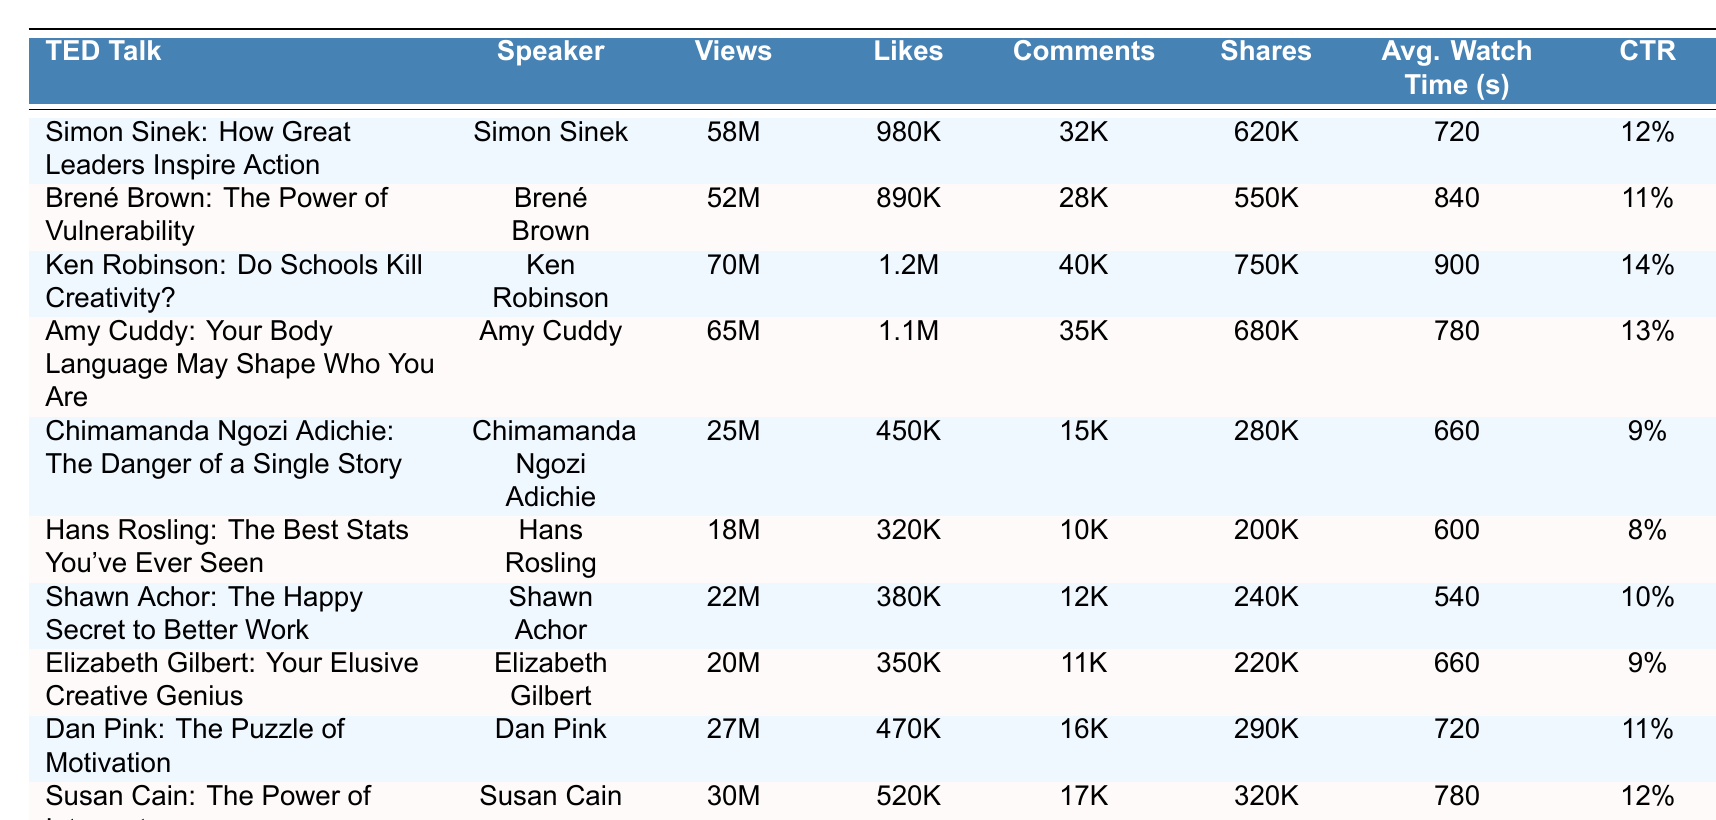What TED Talk has the highest number of views? The table shows the views column, and the TED Talk with the highest number of views is "Ken Robinson: Do Schools Kill Creativity?" with 70 million views.
Answer: Ken Robinson: Do Schools Kill Creativity? Which speaker has the least number of shares? Checking the shares column, Hans Rosling's talk "The Best Stats You've Ever Seen" has the least shares at 200,000.
Answer: Hans Rosling What is the total number of likes for all TED Talks in the table? To find the total likes, we add all the likes together: 980,000 + 890,000 + 1,200,000 + 1,100,000 + 450,000 + 320,000 + 380,000 + 350,000 + 470,000 + 520,000 = 6,360,000.
Answer: 6,360,000 How many TED Talks have an average watch time greater than 750 seconds? We look at the average watch time column and find that Simon Sinek, Brené Brown, Ken Robinson, Amy Cuddy, and Susan Cain have watch times greater than 750 seconds. That's 5 TED Talks.
Answer: 5 What is the average click-through rate for these TED Talks? We sum up the click-through rates: 0.12 + 0.11 + 0.14 + 0.13 + 0.09 + 0.08 + 0.10 + 0.09 + 0.11 + 0.12 = 1.19, and then divide by the number of TED Talks (10) to get 1.19 / 10 = 0.119. Thus, the average click-through rate is 11.9%.
Answer: 11.9% Is the average watch time associated with a higher number of shares for TED Talks? To analyze this, we must compare the average watch times with the shares. The TED Talks with the highest shares (like Ken Robinson and Amy Cuddy) also tend to have higher average watch times (900 and 780 seconds respectively). This trend suggests a correlation, but further statistical analysis would be needed for confirmation.
Answer: Yes, generally higher average watch time correlates with more shares Which TED Talk speaker had the highest subscriber gain? Looking at the subscriber gain column, Ken Robinson's "Do Schools Kill Creativity?" had the highest gain of 55,000 subscribers.
Answer: Ken Robinson How many likes does Chimamanda Ngozi Adichie's TED Talk have in comparison to the average likes of all talks? Chimamanda Ngozi Adichie has 450,000 likes. The average likes across all talks is 636,000. The difference is 636,000 - 450,000 = 186,000, meaning her likes are 186,000 below the average.
Answer: 186,000 below average Which TED Talk had the most comments? By checking the comments column, Ken Robinson's TED Talk received the most comments at 40,000.
Answer: Ken Robinson: Do Schools Kill Creativity? Does the average number of views correlate with the number of shares? Analyzing the data, we see TED Talks with more views like Ken Robinson and Amy Cuddy have corresponding high shares. This implies a positive correlation, but a calculation of correlation coefficients would be necessary for a precise conclusion.
Answer: Yes, generally higher views correlate with more shares 